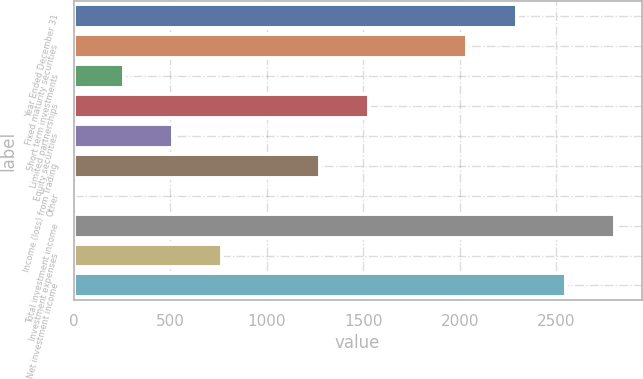Convert chart. <chart><loc_0><loc_0><loc_500><loc_500><bar_chart><fcel>Year Ended December 31<fcel>Fixed maturity securities<fcel>Short term investments<fcel>Limited partnerships<fcel>Equity securities<fcel>Income (loss) from Trading<fcel>Other<fcel>Total investment income<fcel>Investment expenses<fcel>Net investment income<nl><fcel>2294.7<fcel>2040.4<fcel>260.3<fcel>1531.8<fcel>514.6<fcel>1277.5<fcel>6<fcel>2803.3<fcel>768.9<fcel>2549<nl></chart> 